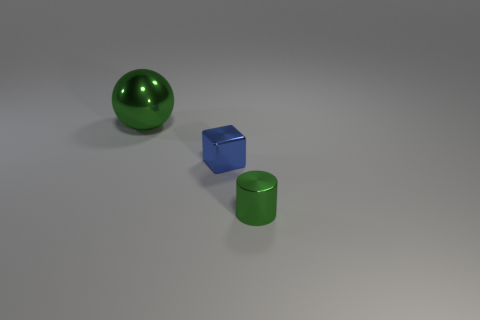Does the tiny cylinder have the same color as the large ball?
Make the answer very short. Yes. Are there an equal number of green metallic objects that are in front of the large green shiny thing and large green spheres in front of the tiny blue block?
Your answer should be compact. No. What color is the thing that is on the left side of the tiny blue shiny block?
Keep it short and to the point. Green. Are there an equal number of tiny blocks that are left of the block and big green spheres?
Provide a short and direct response. No. How many other things are the same shape as the small green object?
Give a very brief answer. 0. How many small cubes are right of the tiny metallic cylinder?
Give a very brief answer. 0. Are there any cyan cylinders?
Provide a succinct answer. No. How many other objects are there of the same size as the green sphere?
Your answer should be very brief. 0. There is a thing behind the small blue cube; does it have the same color as the small metal object to the left of the cylinder?
Offer a terse response. No. How many rubber objects are large balls or blue objects?
Give a very brief answer. 0. 